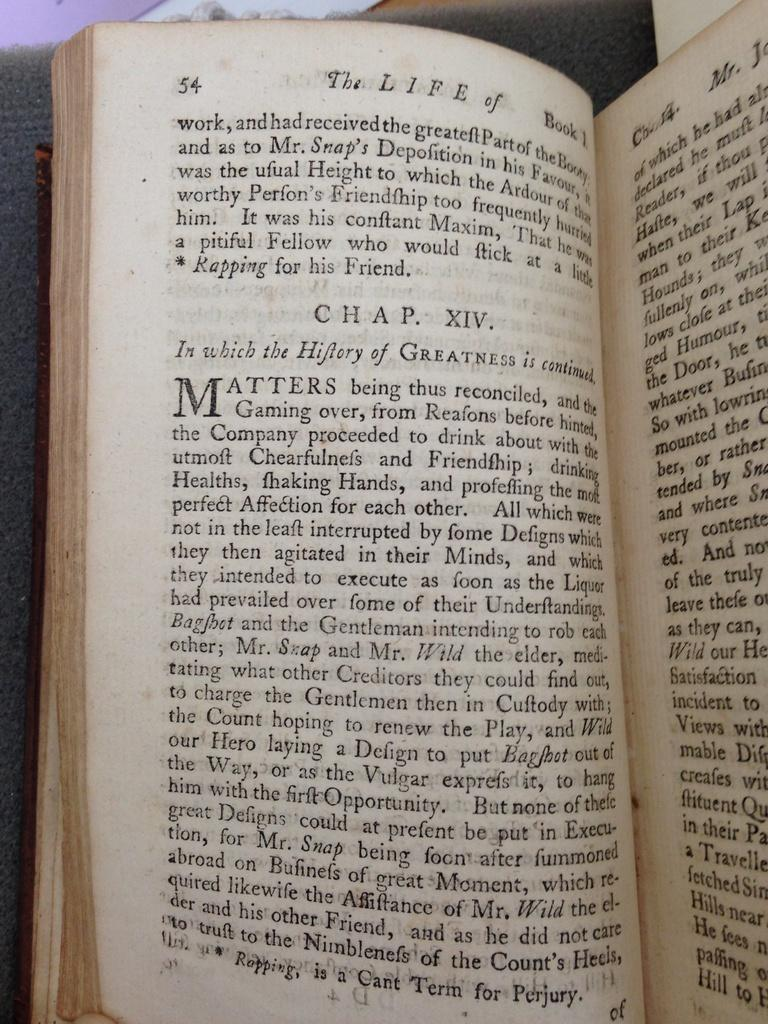<image>
Summarize the visual content of the image. On page 54, chapter XIV starts with the words "In which". 